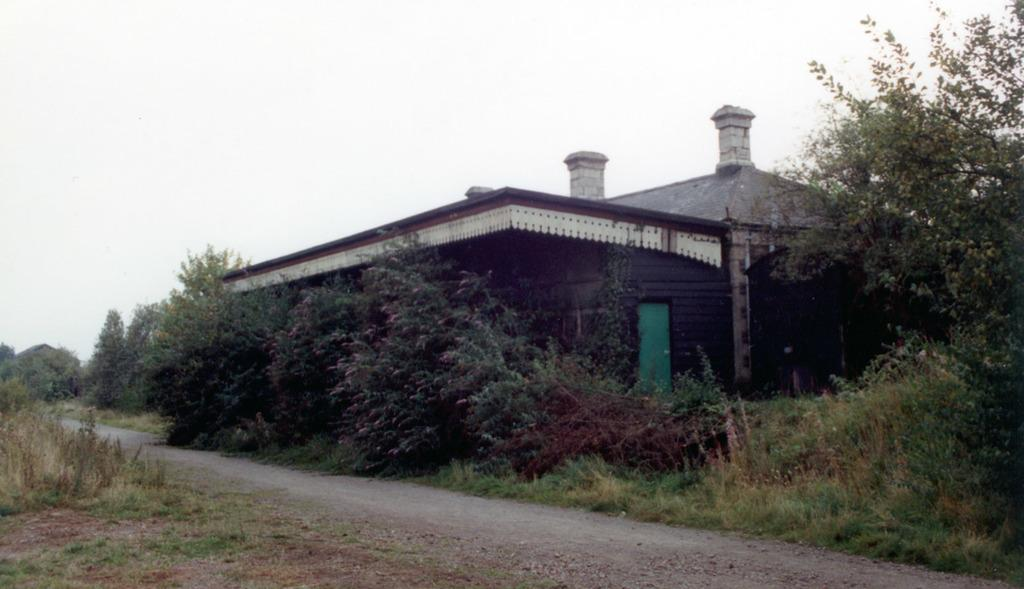What type of vegetation can be seen in the image? There is grass and plants in the image. What type of structure is present in the image? There is a house in the image. What architectural feature can be seen on the house? There are pillars in the image. What is the entrance to the house in the image? There is a door in the image. What else can be seen in the image besides the house and vegetation? There are trees in the image. What is visible in the background of the image? The sky is visible in the background of the image. How many mice are sitting on the grass in the image? There are no mice present in the image; it features grass, plants, a house, pillars, a door, trees, and a visible sky. What type of hands can be seen holding the plants in the image? There are no hands holding the plants in the image; the plants are standing on their own. 